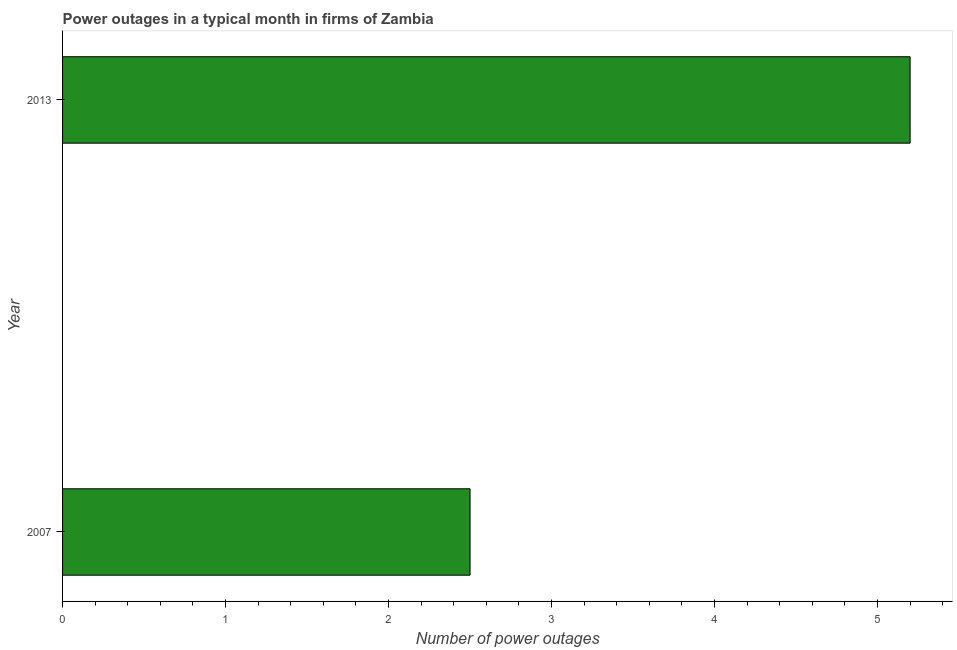What is the title of the graph?
Give a very brief answer. Power outages in a typical month in firms of Zambia. What is the label or title of the X-axis?
Keep it short and to the point. Number of power outages. Across all years, what is the minimum number of power outages?
Provide a short and direct response. 2.5. In which year was the number of power outages maximum?
Your response must be concise. 2013. What is the average number of power outages per year?
Give a very brief answer. 3.85. What is the median number of power outages?
Make the answer very short. 3.85. What is the ratio of the number of power outages in 2007 to that in 2013?
Your response must be concise. 0.48. How many bars are there?
Provide a succinct answer. 2. What is the difference between two consecutive major ticks on the X-axis?
Ensure brevity in your answer.  1. Are the values on the major ticks of X-axis written in scientific E-notation?
Provide a succinct answer. No. What is the Number of power outages of 2007?
Keep it short and to the point. 2.5. What is the difference between the Number of power outages in 2007 and 2013?
Provide a succinct answer. -2.7. What is the ratio of the Number of power outages in 2007 to that in 2013?
Your answer should be compact. 0.48. 